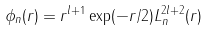Convert formula to latex. <formula><loc_0><loc_0><loc_500><loc_500>\phi _ { n } ( r ) = r ^ { l + 1 } \exp ( - r / 2 ) L _ { n } ^ { 2 l + 2 } ( r )</formula> 